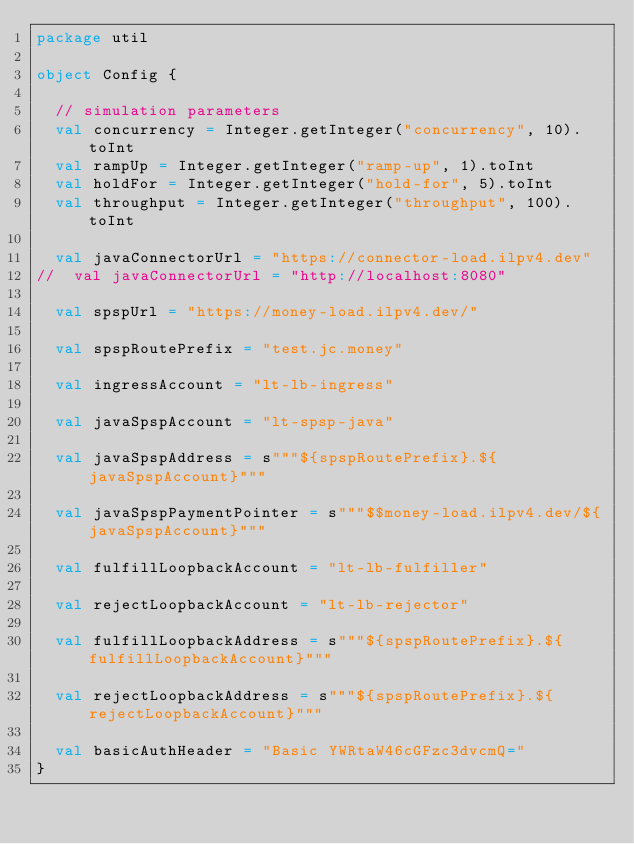<code> <loc_0><loc_0><loc_500><loc_500><_Scala_>package util

object Config {

  // simulation parameters
  val concurrency = Integer.getInteger("concurrency", 10).toInt
  val rampUp = Integer.getInteger("ramp-up", 1).toInt
  val holdFor = Integer.getInteger("hold-for", 5).toInt
  val throughput = Integer.getInteger("throughput", 100).toInt

  val javaConnectorUrl = "https://connector-load.ilpv4.dev"
//  val javaConnectorUrl = "http://localhost:8080"

  val spspUrl = "https://money-load.ilpv4.dev/"

  val spspRoutePrefix = "test.jc.money"

  val ingressAccount = "lt-lb-ingress"

  val javaSpspAccount = "lt-spsp-java"

  val javaSpspAddress = s"""${spspRoutePrefix}.${javaSpspAccount}"""

  val javaSpspPaymentPointer = s"""$$money-load.ilpv4.dev/${javaSpspAccount}"""

  val fulfillLoopbackAccount = "lt-lb-fulfiller"

  val rejectLoopbackAccount = "lt-lb-rejector"

  val fulfillLoopbackAddress = s"""${spspRoutePrefix}.${fulfillLoopbackAccount}"""

  val rejectLoopbackAddress = s"""${spspRoutePrefix}.${rejectLoopbackAccount}"""

  val basicAuthHeader = "Basic YWRtaW46cGFzc3dvcmQ="
}
</code> 